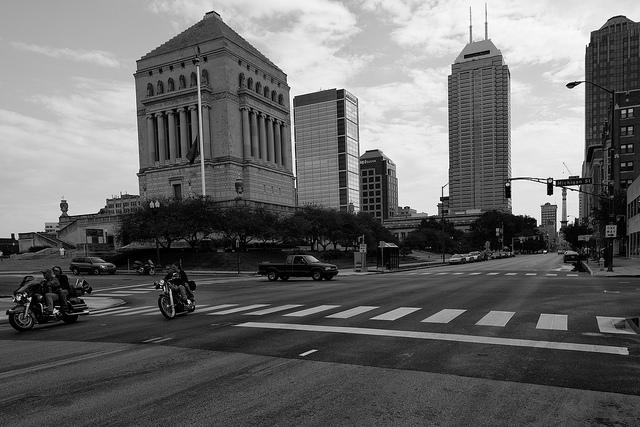What did the motorcycle near the crosswalk just do?

Choices:
A) turn
B) fall
C) break
D) crash turn 